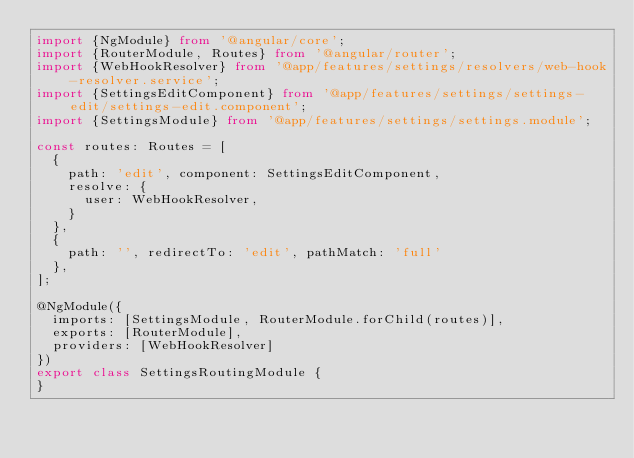Convert code to text. <code><loc_0><loc_0><loc_500><loc_500><_TypeScript_>import {NgModule} from '@angular/core';
import {RouterModule, Routes} from '@angular/router';
import {WebHookResolver} from '@app/features/settings/resolvers/web-hook-resolver.service';
import {SettingsEditComponent} from '@app/features/settings/settings-edit/settings-edit.component';
import {SettingsModule} from '@app/features/settings/settings.module';

const routes: Routes = [
  {
    path: 'edit', component: SettingsEditComponent,
    resolve: {
      user: WebHookResolver,
    }
  },
  {
    path: '', redirectTo: 'edit', pathMatch: 'full'
  },
];

@NgModule({
  imports: [SettingsModule, RouterModule.forChild(routes)],
  exports: [RouterModule],
  providers: [WebHookResolver]
})
export class SettingsRoutingModule {
}
</code> 